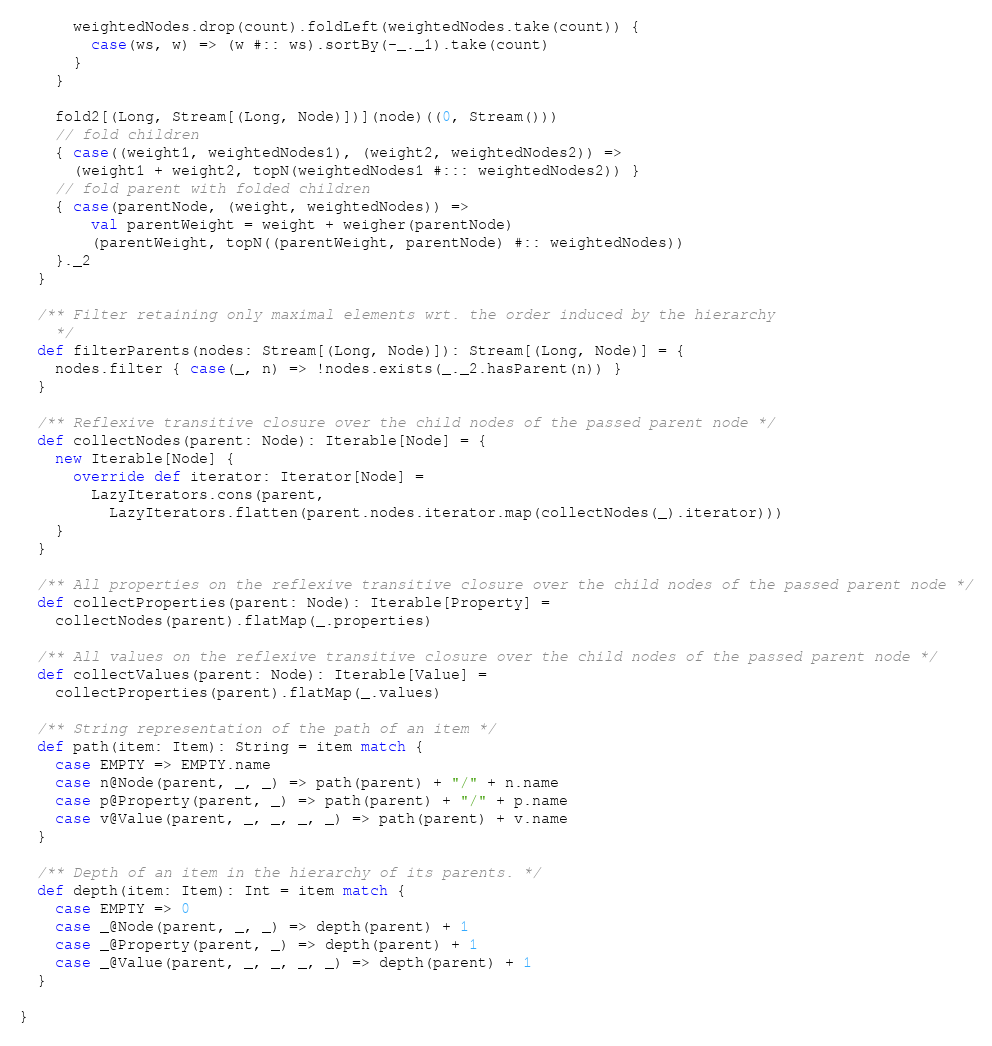Convert code to text. <code><loc_0><loc_0><loc_500><loc_500><_Scala_>      weightedNodes.drop(count).foldLeft(weightedNodes.take(count)) {
        case(ws, w) => (w #:: ws).sortBy(-_._1).take(count)
      }
    }

    fold2[(Long, Stream[(Long, Node)])](node)((0, Stream()))
    // fold children
    { case((weight1, weightedNodes1), (weight2, weightedNodes2)) =>
      (weight1 + weight2, topN(weightedNodes1 #::: weightedNodes2)) }
    // fold parent with folded children
    { case(parentNode, (weight, weightedNodes)) =>
        val parentWeight = weight + weigher(parentNode)
        (parentWeight, topN((parentWeight, parentNode) #:: weightedNodes))
    }._2
  }

  /** Filter retaining only maximal elements wrt. the order induced by the hierarchy
    */
  def filterParents(nodes: Stream[(Long, Node)]): Stream[(Long, Node)] = {
    nodes.filter { case(_, n) => !nodes.exists(_._2.hasParent(n)) }
  }

  /** Reflexive transitive closure over the child nodes of the passed parent node */
  def collectNodes(parent: Node): Iterable[Node] = {
    new Iterable[Node] {
      override def iterator: Iterator[Node] =
        LazyIterators.cons(parent,
          LazyIterators.flatten(parent.nodes.iterator.map(collectNodes(_).iterator)))
    }
  }

  /** All properties on the reflexive transitive closure over the child nodes of the passed parent node */
  def collectProperties(parent: Node): Iterable[Property] =
    collectNodes(parent).flatMap(_.properties)

  /** All values on the reflexive transitive closure over the child nodes of the passed parent node */
  def collectValues(parent: Node): Iterable[Value] =
    collectProperties(parent).flatMap(_.values)

  /** String representation of the path of an item */
  def path(item: Item): String = item match {
    case EMPTY => EMPTY.name
    case n@Node(parent, _, _) => path(parent) + "/" + n.name
    case p@Property(parent, _) => path(parent) + "/" + p.name
    case v@Value(parent, _, _, _, _) => path(parent) + v.name
  }

  /** Depth of an item in the hierarchy of its parents. */
  def depth(item: Item): Int = item match {
    case EMPTY => 0
    case _@Node(parent, _, _) => depth(parent) + 1
    case _@Property(parent, _) => depth(parent) + 1
    case _@Value(parent, _, _, _, _) => depth(parent) + 1
  }

}
</code> 